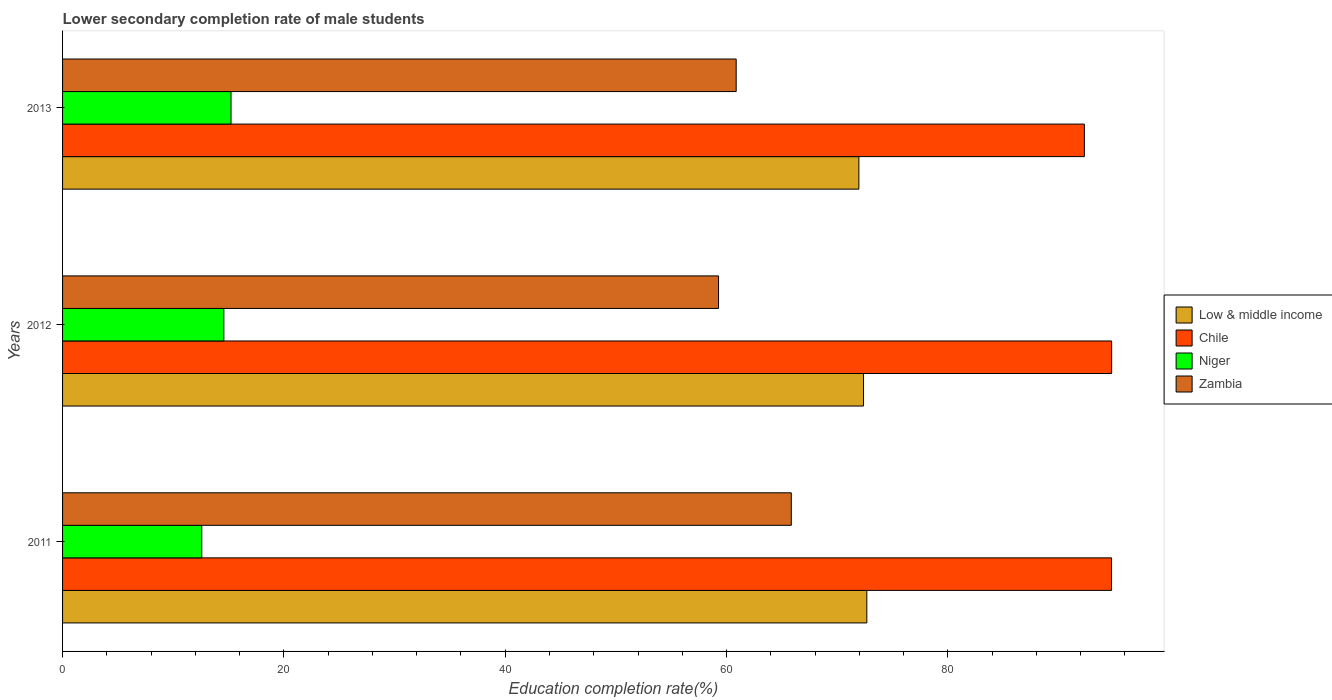How many groups of bars are there?
Give a very brief answer. 3. Are the number of bars per tick equal to the number of legend labels?
Your answer should be compact. Yes. Are the number of bars on each tick of the Y-axis equal?
Offer a very short reply. Yes. How many bars are there on the 1st tick from the bottom?
Offer a terse response. 4. What is the lower secondary completion rate of male students in Chile in 2011?
Provide a short and direct response. 94.79. Across all years, what is the maximum lower secondary completion rate of male students in Zambia?
Offer a terse response. 65.85. Across all years, what is the minimum lower secondary completion rate of male students in Niger?
Provide a short and direct response. 12.58. In which year was the lower secondary completion rate of male students in Chile maximum?
Give a very brief answer. 2012. What is the total lower secondary completion rate of male students in Chile in the graph?
Give a very brief answer. 281.92. What is the difference between the lower secondary completion rate of male students in Zambia in 2012 and that in 2013?
Make the answer very short. -1.59. What is the difference between the lower secondary completion rate of male students in Low & middle income in 2013 and the lower secondary completion rate of male students in Chile in 2012?
Your answer should be very brief. -22.84. What is the average lower secondary completion rate of male students in Low & middle income per year?
Your answer should be very brief. 72.34. In the year 2012, what is the difference between the lower secondary completion rate of male students in Low & middle income and lower secondary completion rate of male students in Zambia?
Keep it short and to the point. 13.1. In how many years, is the lower secondary completion rate of male students in Niger greater than 28 %?
Keep it short and to the point. 0. What is the ratio of the lower secondary completion rate of male students in Niger in 2011 to that in 2013?
Provide a short and direct response. 0.83. Is the lower secondary completion rate of male students in Low & middle income in 2011 less than that in 2012?
Your response must be concise. No. Is the difference between the lower secondary completion rate of male students in Low & middle income in 2011 and 2012 greater than the difference between the lower secondary completion rate of male students in Zambia in 2011 and 2012?
Your response must be concise. No. What is the difference between the highest and the second highest lower secondary completion rate of male students in Chile?
Your response must be concise. 0.01. What is the difference between the highest and the lowest lower secondary completion rate of male students in Niger?
Provide a succinct answer. 2.64. In how many years, is the lower secondary completion rate of male students in Chile greater than the average lower secondary completion rate of male students in Chile taken over all years?
Make the answer very short. 2. Is the sum of the lower secondary completion rate of male students in Zambia in 2011 and 2013 greater than the maximum lower secondary completion rate of male students in Niger across all years?
Your answer should be very brief. Yes. Is it the case that in every year, the sum of the lower secondary completion rate of male students in Niger and lower secondary completion rate of male students in Chile is greater than the sum of lower secondary completion rate of male students in Low & middle income and lower secondary completion rate of male students in Zambia?
Give a very brief answer. No. What does the 4th bar from the bottom in 2013 represents?
Offer a terse response. Zambia. Is it the case that in every year, the sum of the lower secondary completion rate of male students in Zambia and lower secondary completion rate of male students in Niger is greater than the lower secondary completion rate of male students in Chile?
Provide a short and direct response. No. Are all the bars in the graph horizontal?
Give a very brief answer. Yes. Does the graph contain any zero values?
Offer a very short reply. No. Where does the legend appear in the graph?
Ensure brevity in your answer.  Center right. How are the legend labels stacked?
Your answer should be compact. Vertical. What is the title of the graph?
Offer a terse response. Lower secondary completion rate of male students. What is the label or title of the X-axis?
Provide a succinct answer. Education completion rate(%). What is the Education completion rate(%) in Low & middle income in 2011?
Ensure brevity in your answer.  72.68. What is the Education completion rate(%) in Chile in 2011?
Make the answer very short. 94.79. What is the Education completion rate(%) in Niger in 2011?
Offer a very short reply. 12.58. What is the Education completion rate(%) of Zambia in 2011?
Your answer should be compact. 65.85. What is the Education completion rate(%) of Low & middle income in 2012?
Your answer should be very brief. 72.38. What is the Education completion rate(%) of Chile in 2012?
Offer a very short reply. 94.8. What is the Education completion rate(%) in Niger in 2012?
Provide a short and direct response. 14.57. What is the Education completion rate(%) of Zambia in 2012?
Ensure brevity in your answer.  59.28. What is the Education completion rate(%) in Low & middle income in 2013?
Provide a short and direct response. 71.96. What is the Education completion rate(%) in Chile in 2013?
Your answer should be compact. 92.33. What is the Education completion rate(%) in Niger in 2013?
Offer a very short reply. 15.22. What is the Education completion rate(%) in Zambia in 2013?
Your response must be concise. 60.87. Across all years, what is the maximum Education completion rate(%) of Low & middle income?
Offer a very short reply. 72.68. Across all years, what is the maximum Education completion rate(%) of Chile?
Offer a terse response. 94.8. Across all years, what is the maximum Education completion rate(%) in Niger?
Your answer should be compact. 15.22. Across all years, what is the maximum Education completion rate(%) in Zambia?
Offer a very short reply. 65.85. Across all years, what is the minimum Education completion rate(%) of Low & middle income?
Your response must be concise. 71.96. Across all years, what is the minimum Education completion rate(%) in Chile?
Ensure brevity in your answer.  92.33. Across all years, what is the minimum Education completion rate(%) of Niger?
Provide a short and direct response. 12.58. Across all years, what is the minimum Education completion rate(%) of Zambia?
Make the answer very short. 59.28. What is the total Education completion rate(%) of Low & middle income in the graph?
Your answer should be very brief. 217.01. What is the total Education completion rate(%) in Chile in the graph?
Ensure brevity in your answer.  281.92. What is the total Education completion rate(%) in Niger in the graph?
Ensure brevity in your answer.  42.38. What is the total Education completion rate(%) in Zambia in the graph?
Your response must be concise. 185.99. What is the difference between the Education completion rate(%) of Low & middle income in 2011 and that in 2012?
Give a very brief answer. 0.3. What is the difference between the Education completion rate(%) of Chile in 2011 and that in 2012?
Make the answer very short. -0.01. What is the difference between the Education completion rate(%) of Niger in 2011 and that in 2012?
Ensure brevity in your answer.  -1.99. What is the difference between the Education completion rate(%) of Zambia in 2011 and that in 2012?
Make the answer very short. 6.57. What is the difference between the Education completion rate(%) of Low & middle income in 2011 and that in 2013?
Your answer should be compact. 0.72. What is the difference between the Education completion rate(%) of Chile in 2011 and that in 2013?
Give a very brief answer. 2.45. What is the difference between the Education completion rate(%) of Niger in 2011 and that in 2013?
Keep it short and to the point. -2.64. What is the difference between the Education completion rate(%) in Zambia in 2011 and that in 2013?
Ensure brevity in your answer.  4.98. What is the difference between the Education completion rate(%) in Low & middle income in 2012 and that in 2013?
Offer a terse response. 0.42. What is the difference between the Education completion rate(%) in Chile in 2012 and that in 2013?
Offer a terse response. 2.46. What is the difference between the Education completion rate(%) in Niger in 2012 and that in 2013?
Ensure brevity in your answer.  -0.65. What is the difference between the Education completion rate(%) of Zambia in 2012 and that in 2013?
Provide a succinct answer. -1.59. What is the difference between the Education completion rate(%) in Low & middle income in 2011 and the Education completion rate(%) in Chile in 2012?
Provide a short and direct response. -22.12. What is the difference between the Education completion rate(%) of Low & middle income in 2011 and the Education completion rate(%) of Niger in 2012?
Your answer should be compact. 58.1. What is the difference between the Education completion rate(%) in Low & middle income in 2011 and the Education completion rate(%) in Zambia in 2012?
Give a very brief answer. 13.4. What is the difference between the Education completion rate(%) of Chile in 2011 and the Education completion rate(%) of Niger in 2012?
Your answer should be very brief. 80.21. What is the difference between the Education completion rate(%) in Chile in 2011 and the Education completion rate(%) in Zambia in 2012?
Your response must be concise. 35.51. What is the difference between the Education completion rate(%) in Niger in 2011 and the Education completion rate(%) in Zambia in 2012?
Ensure brevity in your answer.  -46.7. What is the difference between the Education completion rate(%) of Low & middle income in 2011 and the Education completion rate(%) of Chile in 2013?
Your response must be concise. -19.66. What is the difference between the Education completion rate(%) of Low & middle income in 2011 and the Education completion rate(%) of Niger in 2013?
Provide a short and direct response. 57.45. What is the difference between the Education completion rate(%) of Low & middle income in 2011 and the Education completion rate(%) of Zambia in 2013?
Provide a short and direct response. 11.81. What is the difference between the Education completion rate(%) in Chile in 2011 and the Education completion rate(%) in Niger in 2013?
Your answer should be very brief. 79.56. What is the difference between the Education completion rate(%) of Chile in 2011 and the Education completion rate(%) of Zambia in 2013?
Offer a terse response. 33.92. What is the difference between the Education completion rate(%) in Niger in 2011 and the Education completion rate(%) in Zambia in 2013?
Keep it short and to the point. -48.29. What is the difference between the Education completion rate(%) of Low & middle income in 2012 and the Education completion rate(%) of Chile in 2013?
Give a very brief answer. -19.96. What is the difference between the Education completion rate(%) of Low & middle income in 2012 and the Education completion rate(%) of Niger in 2013?
Provide a short and direct response. 57.15. What is the difference between the Education completion rate(%) in Low & middle income in 2012 and the Education completion rate(%) in Zambia in 2013?
Your answer should be very brief. 11.51. What is the difference between the Education completion rate(%) in Chile in 2012 and the Education completion rate(%) in Niger in 2013?
Offer a terse response. 79.57. What is the difference between the Education completion rate(%) of Chile in 2012 and the Education completion rate(%) of Zambia in 2013?
Offer a terse response. 33.93. What is the difference between the Education completion rate(%) in Niger in 2012 and the Education completion rate(%) in Zambia in 2013?
Provide a short and direct response. -46.29. What is the average Education completion rate(%) of Low & middle income per year?
Your answer should be compact. 72.34. What is the average Education completion rate(%) of Chile per year?
Offer a terse response. 93.97. What is the average Education completion rate(%) in Niger per year?
Make the answer very short. 14.13. What is the average Education completion rate(%) of Zambia per year?
Make the answer very short. 62. In the year 2011, what is the difference between the Education completion rate(%) of Low & middle income and Education completion rate(%) of Chile?
Offer a terse response. -22.11. In the year 2011, what is the difference between the Education completion rate(%) in Low & middle income and Education completion rate(%) in Niger?
Ensure brevity in your answer.  60.1. In the year 2011, what is the difference between the Education completion rate(%) of Low & middle income and Education completion rate(%) of Zambia?
Your answer should be compact. 6.83. In the year 2011, what is the difference between the Education completion rate(%) in Chile and Education completion rate(%) in Niger?
Give a very brief answer. 82.21. In the year 2011, what is the difference between the Education completion rate(%) of Chile and Education completion rate(%) of Zambia?
Give a very brief answer. 28.94. In the year 2011, what is the difference between the Education completion rate(%) of Niger and Education completion rate(%) of Zambia?
Offer a very short reply. -53.27. In the year 2012, what is the difference between the Education completion rate(%) of Low & middle income and Education completion rate(%) of Chile?
Your answer should be compact. -22.42. In the year 2012, what is the difference between the Education completion rate(%) of Low & middle income and Education completion rate(%) of Niger?
Offer a terse response. 57.8. In the year 2012, what is the difference between the Education completion rate(%) in Low & middle income and Education completion rate(%) in Zambia?
Your response must be concise. 13.1. In the year 2012, what is the difference between the Education completion rate(%) in Chile and Education completion rate(%) in Niger?
Give a very brief answer. 80.22. In the year 2012, what is the difference between the Education completion rate(%) of Chile and Education completion rate(%) of Zambia?
Your answer should be very brief. 35.52. In the year 2012, what is the difference between the Education completion rate(%) in Niger and Education completion rate(%) in Zambia?
Offer a very short reply. -44.7. In the year 2013, what is the difference between the Education completion rate(%) in Low & middle income and Education completion rate(%) in Chile?
Ensure brevity in your answer.  -20.38. In the year 2013, what is the difference between the Education completion rate(%) of Low & middle income and Education completion rate(%) of Niger?
Your answer should be very brief. 56.73. In the year 2013, what is the difference between the Education completion rate(%) of Low & middle income and Education completion rate(%) of Zambia?
Give a very brief answer. 11.09. In the year 2013, what is the difference between the Education completion rate(%) of Chile and Education completion rate(%) of Niger?
Offer a terse response. 77.11. In the year 2013, what is the difference between the Education completion rate(%) in Chile and Education completion rate(%) in Zambia?
Your answer should be very brief. 31.46. In the year 2013, what is the difference between the Education completion rate(%) in Niger and Education completion rate(%) in Zambia?
Keep it short and to the point. -45.65. What is the ratio of the Education completion rate(%) of Chile in 2011 to that in 2012?
Keep it short and to the point. 1. What is the ratio of the Education completion rate(%) in Niger in 2011 to that in 2012?
Your response must be concise. 0.86. What is the ratio of the Education completion rate(%) of Zambia in 2011 to that in 2012?
Offer a terse response. 1.11. What is the ratio of the Education completion rate(%) in Low & middle income in 2011 to that in 2013?
Your answer should be compact. 1.01. What is the ratio of the Education completion rate(%) of Chile in 2011 to that in 2013?
Provide a succinct answer. 1.03. What is the ratio of the Education completion rate(%) of Niger in 2011 to that in 2013?
Ensure brevity in your answer.  0.83. What is the ratio of the Education completion rate(%) in Zambia in 2011 to that in 2013?
Your response must be concise. 1.08. What is the ratio of the Education completion rate(%) in Low & middle income in 2012 to that in 2013?
Ensure brevity in your answer.  1.01. What is the ratio of the Education completion rate(%) in Chile in 2012 to that in 2013?
Give a very brief answer. 1.03. What is the ratio of the Education completion rate(%) in Niger in 2012 to that in 2013?
Provide a short and direct response. 0.96. What is the ratio of the Education completion rate(%) of Zambia in 2012 to that in 2013?
Your answer should be very brief. 0.97. What is the difference between the highest and the second highest Education completion rate(%) of Low & middle income?
Keep it short and to the point. 0.3. What is the difference between the highest and the second highest Education completion rate(%) in Chile?
Give a very brief answer. 0.01. What is the difference between the highest and the second highest Education completion rate(%) in Niger?
Give a very brief answer. 0.65. What is the difference between the highest and the second highest Education completion rate(%) in Zambia?
Offer a terse response. 4.98. What is the difference between the highest and the lowest Education completion rate(%) of Low & middle income?
Offer a very short reply. 0.72. What is the difference between the highest and the lowest Education completion rate(%) in Chile?
Provide a short and direct response. 2.46. What is the difference between the highest and the lowest Education completion rate(%) in Niger?
Provide a succinct answer. 2.64. What is the difference between the highest and the lowest Education completion rate(%) of Zambia?
Provide a succinct answer. 6.57. 